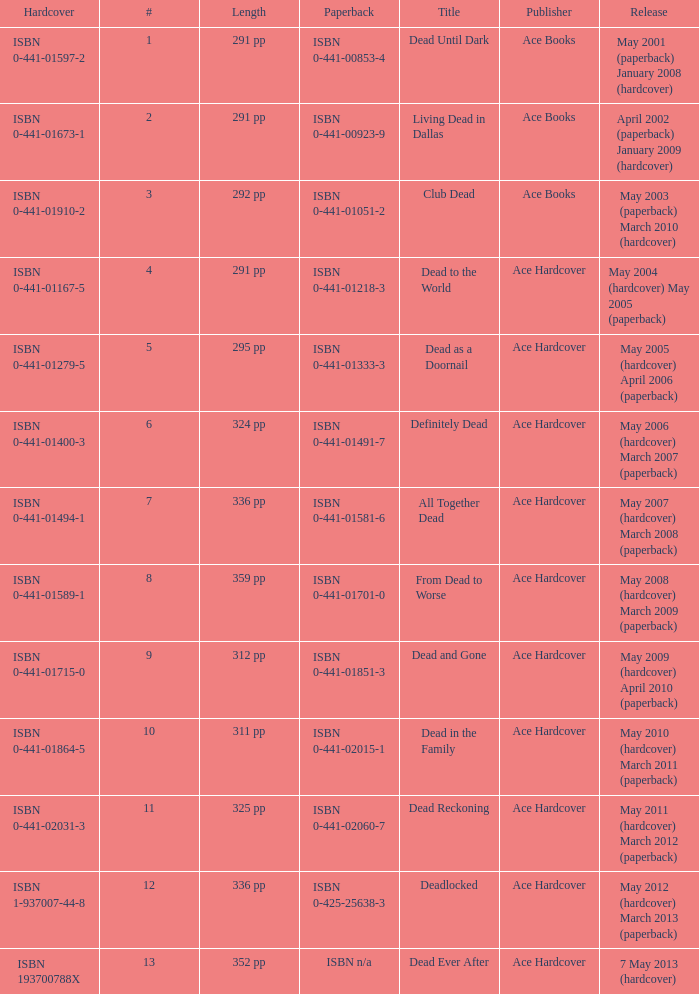How many publishers put out isbn 193700788x? 1.0. Parse the table in full. {'header': ['Hardcover', '#', 'Length', 'Paperback', 'Title', 'Publisher', 'Release'], 'rows': [['ISBN 0-441-01597-2', '1', '291 pp', 'ISBN 0-441-00853-4', 'Dead Until Dark', 'Ace Books', 'May 2001 (paperback) January 2008 (hardcover)'], ['ISBN 0-441-01673-1', '2', '291 pp', 'ISBN 0-441-00923-9', 'Living Dead in Dallas', 'Ace Books', 'April 2002 (paperback) January 2009 (hardcover)'], ['ISBN 0-441-01910-2', '3', '292 pp', 'ISBN 0-441-01051-2', 'Club Dead', 'Ace Books', 'May 2003 (paperback) March 2010 (hardcover)'], ['ISBN 0-441-01167-5', '4', '291 pp', 'ISBN 0-441-01218-3', 'Dead to the World', 'Ace Hardcover', 'May 2004 (hardcover) May 2005 (paperback)'], ['ISBN 0-441-01279-5', '5', '295 pp', 'ISBN 0-441-01333-3', 'Dead as a Doornail', 'Ace Hardcover', 'May 2005 (hardcover) April 2006 (paperback)'], ['ISBN 0-441-01400-3', '6', '324 pp', 'ISBN 0-441-01491-7', 'Definitely Dead', 'Ace Hardcover', 'May 2006 (hardcover) March 2007 (paperback)'], ['ISBN 0-441-01494-1', '7', '336 pp', 'ISBN 0-441-01581-6', 'All Together Dead', 'Ace Hardcover', 'May 2007 (hardcover) March 2008 (paperback)'], ['ISBN 0-441-01589-1', '8', '359 pp', 'ISBN 0-441-01701-0', 'From Dead to Worse', 'Ace Hardcover', 'May 2008 (hardcover) March 2009 (paperback)'], ['ISBN 0-441-01715-0', '9', '312 pp', 'ISBN 0-441-01851-3', 'Dead and Gone', 'Ace Hardcover', 'May 2009 (hardcover) April 2010 (paperback)'], ['ISBN 0-441-01864-5', '10', '311 pp', 'ISBN 0-441-02015-1', 'Dead in the Family', 'Ace Hardcover', 'May 2010 (hardcover) March 2011 (paperback)'], ['ISBN 0-441-02031-3', '11', '325 pp', 'ISBN 0-441-02060-7', 'Dead Reckoning', 'Ace Hardcover', 'May 2011 (hardcover) March 2012 (paperback)'], ['ISBN 1-937007-44-8', '12', '336 pp', 'ISBN 0-425-25638-3', 'Deadlocked', 'Ace Hardcover', 'May 2012 (hardcover) March 2013 (paperback)'], ['ISBN 193700788X', '13', '352 pp', 'ISBN n/a', 'Dead Ever After', 'Ace Hardcover', '7 May 2013 (hardcover)']]} 